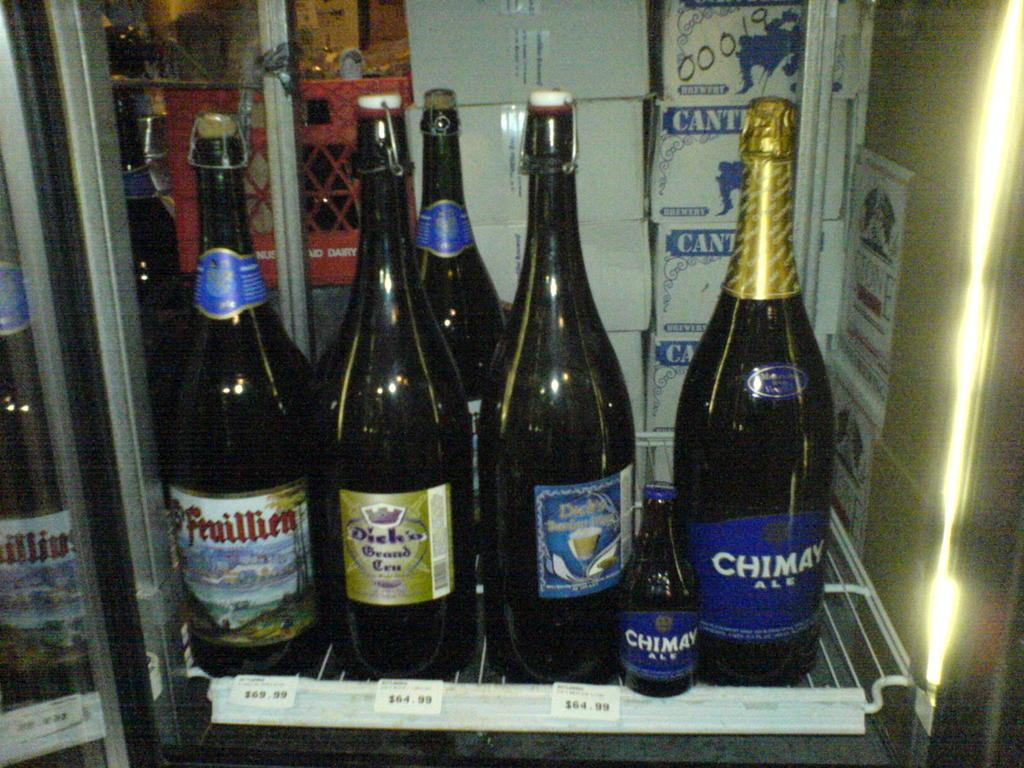What objects are placed on the grills in the image? There are bottles on grills in the image. What can be seen in the background of the image? There are cardboard boxes in the background of the image. What color is the hope in the image? There is no mention of hope in the image, as it is not a visible object or concept that can be assigned a color. 